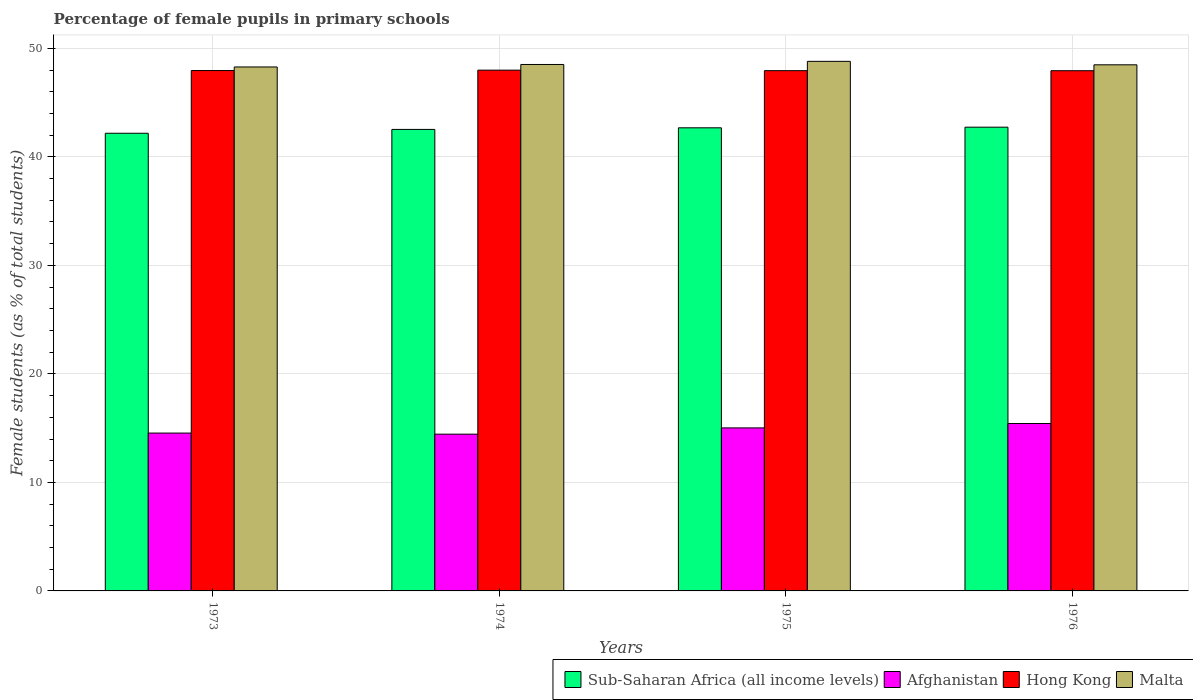How many different coloured bars are there?
Ensure brevity in your answer.  4. How many groups of bars are there?
Provide a succinct answer. 4. Are the number of bars per tick equal to the number of legend labels?
Your answer should be compact. Yes. Are the number of bars on each tick of the X-axis equal?
Your answer should be very brief. Yes. How many bars are there on the 4th tick from the right?
Offer a very short reply. 4. What is the label of the 2nd group of bars from the left?
Provide a short and direct response. 1974. What is the percentage of female pupils in primary schools in Hong Kong in 1975?
Make the answer very short. 47.94. Across all years, what is the maximum percentage of female pupils in primary schools in Hong Kong?
Your answer should be compact. 47.99. Across all years, what is the minimum percentage of female pupils in primary schools in Afghanistan?
Your response must be concise. 14.45. In which year was the percentage of female pupils in primary schools in Afghanistan maximum?
Your answer should be very brief. 1976. In which year was the percentage of female pupils in primary schools in Sub-Saharan Africa (all income levels) minimum?
Ensure brevity in your answer.  1973. What is the total percentage of female pupils in primary schools in Sub-Saharan Africa (all income levels) in the graph?
Give a very brief answer. 170.12. What is the difference between the percentage of female pupils in primary schools in Hong Kong in 1974 and that in 1975?
Give a very brief answer. 0.05. What is the difference between the percentage of female pupils in primary schools in Sub-Saharan Africa (all income levels) in 1975 and the percentage of female pupils in primary schools in Hong Kong in 1974?
Provide a succinct answer. -5.31. What is the average percentage of female pupils in primary schools in Malta per year?
Ensure brevity in your answer.  48.52. In the year 1973, what is the difference between the percentage of female pupils in primary schools in Afghanistan and percentage of female pupils in primary schools in Hong Kong?
Your answer should be very brief. -33.41. What is the ratio of the percentage of female pupils in primary schools in Hong Kong in 1975 to that in 1976?
Provide a short and direct response. 1. What is the difference between the highest and the second highest percentage of female pupils in primary schools in Hong Kong?
Offer a very short reply. 0.04. What is the difference between the highest and the lowest percentage of female pupils in primary schools in Sub-Saharan Africa (all income levels)?
Provide a short and direct response. 0.56. In how many years, is the percentage of female pupils in primary schools in Malta greater than the average percentage of female pupils in primary schools in Malta taken over all years?
Your answer should be compact. 1. Is the sum of the percentage of female pupils in primary schools in Sub-Saharan Africa (all income levels) in 1975 and 1976 greater than the maximum percentage of female pupils in primary schools in Hong Kong across all years?
Offer a very short reply. Yes. Is it the case that in every year, the sum of the percentage of female pupils in primary schools in Sub-Saharan Africa (all income levels) and percentage of female pupils in primary schools in Afghanistan is greater than the sum of percentage of female pupils in primary schools in Hong Kong and percentage of female pupils in primary schools in Malta?
Your response must be concise. No. What does the 2nd bar from the left in 1976 represents?
Your response must be concise. Afghanistan. What does the 4th bar from the right in 1975 represents?
Make the answer very short. Sub-Saharan Africa (all income levels). Is it the case that in every year, the sum of the percentage of female pupils in primary schools in Sub-Saharan Africa (all income levels) and percentage of female pupils in primary schools in Hong Kong is greater than the percentage of female pupils in primary schools in Malta?
Give a very brief answer. Yes. Are all the bars in the graph horizontal?
Provide a succinct answer. No. What is the difference between two consecutive major ticks on the Y-axis?
Offer a terse response. 10. Does the graph contain any zero values?
Your answer should be very brief. No. Does the graph contain grids?
Ensure brevity in your answer.  Yes. Where does the legend appear in the graph?
Your response must be concise. Bottom right. How many legend labels are there?
Keep it short and to the point. 4. How are the legend labels stacked?
Provide a short and direct response. Horizontal. What is the title of the graph?
Keep it short and to the point. Percentage of female pupils in primary schools. Does "Singapore" appear as one of the legend labels in the graph?
Keep it short and to the point. No. What is the label or title of the Y-axis?
Provide a succinct answer. Female students (as % of total students). What is the Female students (as % of total students) of Sub-Saharan Africa (all income levels) in 1973?
Offer a terse response. 42.18. What is the Female students (as % of total students) in Afghanistan in 1973?
Your response must be concise. 14.55. What is the Female students (as % of total students) of Hong Kong in 1973?
Give a very brief answer. 47.96. What is the Female students (as % of total students) of Malta in 1973?
Keep it short and to the point. 48.29. What is the Female students (as % of total students) of Sub-Saharan Africa (all income levels) in 1974?
Provide a short and direct response. 42.53. What is the Female students (as % of total students) of Afghanistan in 1974?
Your answer should be compact. 14.45. What is the Female students (as % of total students) in Hong Kong in 1974?
Keep it short and to the point. 47.99. What is the Female students (as % of total students) in Malta in 1974?
Make the answer very short. 48.52. What is the Female students (as % of total students) of Sub-Saharan Africa (all income levels) in 1975?
Your response must be concise. 42.68. What is the Female students (as % of total students) of Afghanistan in 1975?
Provide a succinct answer. 15.02. What is the Female students (as % of total students) of Hong Kong in 1975?
Provide a succinct answer. 47.94. What is the Female students (as % of total students) of Malta in 1975?
Make the answer very short. 48.8. What is the Female students (as % of total students) in Sub-Saharan Africa (all income levels) in 1976?
Ensure brevity in your answer.  42.74. What is the Female students (as % of total students) of Afghanistan in 1976?
Offer a terse response. 15.43. What is the Female students (as % of total students) in Hong Kong in 1976?
Your answer should be compact. 47.94. What is the Female students (as % of total students) in Malta in 1976?
Give a very brief answer. 48.48. Across all years, what is the maximum Female students (as % of total students) in Sub-Saharan Africa (all income levels)?
Make the answer very short. 42.74. Across all years, what is the maximum Female students (as % of total students) in Afghanistan?
Provide a short and direct response. 15.43. Across all years, what is the maximum Female students (as % of total students) of Hong Kong?
Your response must be concise. 47.99. Across all years, what is the maximum Female students (as % of total students) in Malta?
Make the answer very short. 48.8. Across all years, what is the minimum Female students (as % of total students) of Sub-Saharan Africa (all income levels)?
Ensure brevity in your answer.  42.18. Across all years, what is the minimum Female students (as % of total students) in Afghanistan?
Provide a short and direct response. 14.45. Across all years, what is the minimum Female students (as % of total students) in Hong Kong?
Offer a terse response. 47.94. Across all years, what is the minimum Female students (as % of total students) of Malta?
Your response must be concise. 48.29. What is the total Female students (as % of total students) in Sub-Saharan Africa (all income levels) in the graph?
Your response must be concise. 170.12. What is the total Female students (as % of total students) of Afghanistan in the graph?
Keep it short and to the point. 59.45. What is the total Female students (as % of total students) in Hong Kong in the graph?
Your response must be concise. 191.84. What is the total Female students (as % of total students) of Malta in the graph?
Offer a terse response. 194.09. What is the difference between the Female students (as % of total students) of Sub-Saharan Africa (all income levels) in 1973 and that in 1974?
Your response must be concise. -0.35. What is the difference between the Female students (as % of total students) in Afghanistan in 1973 and that in 1974?
Your response must be concise. 0.1. What is the difference between the Female students (as % of total students) of Hong Kong in 1973 and that in 1974?
Ensure brevity in your answer.  -0.04. What is the difference between the Female students (as % of total students) in Malta in 1973 and that in 1974?
Give a very brief answer. -0.23. What is the difference between the Female students (as % of total students) in Sub-Saharan Africa (all income levels) in 1973 and that in 1975?
Your answer should be compact. -0.5. What is the difference between the Female students (as % of total students) of Afghanistan in 1973 and that in 1975?
Your answer should be compact. -0.48. What is the difference between the Female students (as % of total students) of Hong Kong in 1973 and that in 1975?
Ensure brevity in your answer.  0.01. What is the difference between the Female students (as % of total students) of Malta in 1973 and that in 1975?
Your answer should be compact. -0.52. What is the difference between the Female students (as % of total students) in Sub-Saharan Africa (all income levels) in 1973 and that in 1976?
Keep it short and to the point. -0.56. What is the difference between the Female students (as % of total students) in Afghanistan in 1973 and that in 1976?
Your response must be concise. -0.88. What is the difference between the Female students (as % of total students) of Hong Kong in 1973 and that in 1976?
Your response must be concise. 0.02. What is the difference between the Female students (as % of total students) of Malta in 1973 and that in 1976?
Offer a very short reply. -0.2. What is the difference between the Female students (as % of total students) of Sub-Saharan Africa (all income levels) in 1974 and that in 1975?
Your answer should be very brief. -0.15. What is the difference between the Female students (as % of total students) in Afghanistan in 1974 and that in 1975?
Offer a terse response. -0.58. What is the difference between the Female students (as % of total students) in Hong Kong in 1974 and that in 1975?
Make the answer very short. 0.05. What is the difference between the Female students (as % of total students) of Malta in 1974 and that in 1975?
Offer a very short reply. -0.29. What is the difference between the Female students (as % of total students) in Sub-Saharan Africa (all income levels) in 1974 and that in 1976?
Provide a succinct answer. -0.21. What is the difference between the Female students (as % of total students) of Afghanistan in 1974 and that in 1976?
Give a very brief answer. -0.98. What is the difference between the Female students (as % of total students) in Hong Kong in 1974 and that in 1976?
Offer a terse response. 0.05. What is the difference between the Female students (as % of total students) of Malta in 1974 and that in 1976?
Your response must be concise. 0.03. What is the difference between the Female students (as % of total students) of Sub-Saharan Africa (all income levels) in 1975 and that in 1976?
Provide a succinct answer. -0.06. What is the difference between the Female students (as % of total students) in Afghanistan in 1975 and that in 1976?
Offer a very short reply. -0.41. What is the difference between the Female students (as % of total students) of Hong Kong in 1975 and that in 1976?
Keep it short and to the point. 0. What is the difference between the Female students (as % of total students) in Malta in 1975 and that in 1976?
Provide a short and direct response. 0.32. What is the difference between the Female students (as % of total students) of Sub-Saharan Africa (all income levels) in 1973 and the Female students (as % of total students) of Afghanistan in 1974?
Ensure brevity in your answer.  27.73. What is the difference between the Female students (as % of total students) in Sub-Saharan Africa (all income levels) in 1973 and the Female students (as % of total students) in Hong Kong in 1974?
Give a very brief answer. -5.82. What is the difference between the Female students (as % of total students) of Sub-Saharan Africa (all income levels) in 1973 and the Female students (as % of total students) of Malta in 1974?
Your response must be concise. -6.34. What is the difference between the Female students (as % of total students) in Afghanistan in 1973 and the Female students (as % of total students) in Hong Kong in 1974?
Provide a succinct answer. -33.45. What is the difference between the Female students (as % of total students) in Afghanistan in 1973 and the Female students (as % of total students) in Malta in 1974?
Keep it short and to the point. -33.97. What is the difference between the Female students (as % of total students) of Hong Kong in 1973 and the Female students (as % of total students) of Malta in 1974?
Provide a short and direct response. -0.56. What is the difference between the Female students (as % of total students) in Sub-Saharan Africa (all income levels) in 1973 and the Female students (as % of total students) in Afghanistan in 1975?
Offer a terse response. 27.15. What is the difference between the Female students (as % of total students) of Sub-Saharan Africa (all income levels) in 1973 and the Female students (as % of total students) of Hong Kong in 1975?
Ensure brevity in your answer.  -5.77. What is the difference between the Female students (as % of total students) in Sub-Saharan Africa (all income levels) in 1973 and the Female students (as % of total students) in Malta in 1975?
Your answer should be very brief. -6.63. What is the difference between the Female students (as % of total students) of Afghanistan in 1973 and the Female students (as % of total students) of Hong Kong in 1975?
Your answer should be compact. -33.4. What is the difference between the Female students (as % of total students) of Afghanistan in 1973 and the Female students (as % of total students) of Malta in 1975?
Ensure brevity in your answer.  -34.26. What is the difference between the Female students (as % of total students) of Hong Kong in 1973 and the Female students (as % of total students) of Malta in 1975?
Offer a very short reply. -0.85. What is the difference between the Female students (as % of total students) of Sub-Saharan Africa (all income levels) in 1973 and the Female students (as % of total students) of Afghanistan in 1976?
Give a very brief answer. 26.75. What is the difference between the Female students (as % of total students) of Sub-Saharan Africa (all income levels) in 1973 and the Female students (as % of total students) of Hong Kong in 1976?
Your response must be concise. -5.77. What is the difference between the Female students (as % of total students) in Sub-Saharan Africa (all income levels) in 1973 and the Female students (as % of total students) in Malta in 1976?
Your answer should be compact. -6.31. What is the difference between the Female students (as % of total students) in Afghanistan in 1973 and the Female students (as % of total students) in Hong Kong in 1976?
Keep it short and to the point. -33.39. What is the difference between the Female students (as % of total students) of Afghanistan in 1973 and the Female students (as % of total students) of Malta in 1976?
Provide a succinct answer. -33.94. What is the difference between the Female students (as % of total students) of Hong Kong in 1973 and the Female students (as % of total students) of Malta in 1976?
Provide a succinct answer. -0.53. What is the difference between the Female students (as % of total students) in Sub-Saharan Africa (all income levels) in 1974 and the Female students (as % of total students) in Afghanistan in 1975?
Provide a succinct answer. 27.51. What is the difference between the Female students (as % of total students) in Sub-Saharan Africa (all income levels) in 1974 and the Female students (as % of total students) in Hong Kong in 1975?
Make the answer very short. -5.41. What is the difference between the Female students (as % of total students) of Sub-Saharan Africa (all income levels) in 1974 and the Female students (as % of total students) of Malta in 1975?
Give a very brief answer. -6.27. What is the difference between the Female students (as % of total students) in Afghanistan in 1974 and the Female students (as % of total students) in Hong Kong in 1975?
Provide a short and direct response. -33.5. What is the difference between the Female students (as % of total students) in Afghanistan in 1974 and the Female students (as % of total students) in Malta in 1975?
Your answer should be compact. -34.36. What is the difference between the Female students (as % of total students) of Hong Kong in 1974 and the Female students (as % of total students) of Malta in 1975?
Give a very brief answer. -0.81. What is the difference between the Female students (as % of total students) of Sub-Saharan Africa (all income levels) in 1974 and the Female students (as % of total students) of Afghanistan in 1976?
Offer a terse response. 27.1. What is the difference between the Female students (as % of total students) of Sub-Saharan Africa (all income levels) in 1974 and the Female students (as % of total students) of Hong Kong in 1976?
Give a very brief answer. -5.41. What is the difference between the Female students (as % of total students) of Sub-Saharan Africa (all income levels) in 1974 and the Female students (as % of total students) of Malta in 1976?
Provide a short and direct response. -5.95. What is the difference between the Female students (as % of total students) of Afghanistan in 1974 and the Female students (as % of total students) of Hong Kong in 1976?
Offer a very short reply. -33.49. What is the difference between the Female students (as % of total students) of Afghanistan in 1974 and the Female students (as % of total students) of Malta in 1976?
Offer a very short reply. -34.04. What is the difference between the Female students (as % of total students) in Hong Kong in 1974 and the Female students (as % of total students) in Malta in 1976?
Provide a short and direct response. -0.49. What is the difference between the Female students (as % of total students) of Sub-Saharan Africa (all income levels) in 1975 and the Female students (as % of total students) of Afghanistan in 1976?
Provide a short and direct response. 27.25. What is the difference between the Female students (as % of total students) in Sub-Saharan Africa (all income levels) in 1975 and the Female students (as % of total students) in Hong Kong in 1976?
Your answer should be very brief. -5.26. What is the difference between the Female students (as % of total students) of Sub-Saharan Africa (all income levels) in 1975 and the Female students (as % of total students) of Malta in 1976?
Offer a terse response. -5.81. What is the difference between the Female students (as % of total students) in Afghanistan in 1975 and the Female students (as % of total students) in Hong Kong in 1976?
Keep it short and to the point. -32.92. What is the difference between the Female students (as % of total students) of Afghanistan in 1975 and the Female students (as % of total students) of Malta in 1976?
Offer a very short reply. -33.46. What is the difference between the Female students (as % of total students) in Hong Kong in 1975 and the Female students (as % of total students) in Malta in 1976?
Offer a terse response. -0.54. What is the average Female students (as % of total students) in Sub-Saharan Africa (all income levels) per year?
Your answer should be very brief. 42.53. What is the average Female students (as % of total students) in Afghanistan per year?
Keep it short and to the point. 14.86. What is the average Female students (as % of total students) of Hong Kong per year?
Offer a very short reply. 47.96. What is the average Female students (as % of total students) of Malta per year?
Give a very brief answer. 48.52. In the year 1973, what is the difference between the Female students (as % of total students) in Sub-Saharan Africa (all income levels) and Female students (as % of total students) in Afghanistan?
Your answer should be very brief. 27.63. In the year 1973, what is the difference between the Female students (as % of total students) of Sub-Saharan Africa (all income levels) and Female students (as % of total students) of Hong Kong?
Your answer should be very brief. -5.78. In the year 1973, what is the difference between the Female students (as % of total students) in Sub-Saharan Africa (all income levels) and Female students (as % of total students) in Malta?
Give a very brief answer. -6.11. In the year 1973, what is the difference between the Female students (as % of total students) in Afghanistan and Female students (as % of total students) in Hong Kong?
Your response must be concise. -33.41. In the year 1973, what is the difference between the Female students (as % of total students) of Afghanistan and Female students (as % of total students) of Malta?
Offer a very short reply. -33.74. In the year 1973, what is the difference between the Female students (as % of total students) of Hong Kong and Female students (as % of total students) of Malta?
Offer a very short reply. -0.33. In the year 1974, what is the difference between the Female students (as % of total students) in Sub-Saharan Africa (all income levels) and Female students (as % of total students) in Afghanistan?
Make the answer very short. 28.08. In the year 1974, what is the difference between the Female students (as % of total students) of Sub-Saharan Africa (all income levels) and Female students (as % of total students) of Hong Kong?
Make the answer very short. -5.46. In the year 1974, what is the difference between the Female students (as % of total students) of Sub-Saharan Africa (all income levels) and Female students (as % of total students) of Malta?
Provide a succinct answer. -5.99. In the year 1974, what is the difference between the Female students (as % of total students) in Afghanistan and Female students (as % of total students) in Hong Kong?
Provide a succinct answer. -33.55. In the year 1974, what is the difference between the Female students (as % of total students) in Afghanistan and Female students (as % of total students) in Malta?
Offer a terse response. -34.07. In the year 1974, what is the difference between the Female students (as % of total students) of Hong Kong and Female students (as % of total students) of Malta?
Give a very brief answer. -0.52. In the year 1975, what is the difference between the Female students (as % of total students) of Sub-Saharan Africa (all income levels) and Female students (as % of total students) of Afghanistan?
Make the answer very short. 27.65. In the year 1975, what is the difference between the Female students (as % of total students) of Sub-Saharan Africa (all income levels) and Female students (as % of total students) of Hong Kong?
Ensure brevity in your answer.  -5.27. In the year 1975, what is the difference between the Female students (as % of total students) in Sub-Saharan Africa (all income levels) and Female students (as % of total students) in Malta?
Offer a terse response. -6.12. In the year 1975, what is the difference between the Female students (as % of total students) of Afghanistan and Female students (as % of total students) of Hong Kong?
Your answer should be compact. -32.92. In the year 1975, what is the difference between the Female students (as % of total students) of Afghanistan and Female students (as % of total students) of Malta?
Offer a very short reply. -33.78. In the year 1975, what is the difference between the Female students (as % of total students) of Hong Kong and Female students (as % of total students) of Malta?
Keep it short and to the point. -0.86. In the year 1976, what is the difference between the Female students (as % of total students) in Sub-Saharan Africa (all income levels) and Female students (as % of total students) in Afghanistan?
Your answer should be compact. 27.31. In the year 1976, what is the difference between the Female students (as % of total students) in Sub-Saharan Africa (all income levels) and Female students (as % of total students) in Hong Kong?
Provide a short and direct response. -5.2. In the year 1976, what is the difference between the Female students (as % of total students) of Sub-Saharan Africa (all income levels) and Female students (as % of total students) of Malta?
Your answer should be compact. -5.75. In the year 1976, what is the difference between the Female students (as % of total students) of Afghanistan and Female students (as % of total students) of Hong Kong?
Offer a very short reply. -32.51. In the year 1976, what is the difference between the Female students (as % of total students) in Afghanistan and Female students (as % of total students) in Malta?
Provide a short and direct response. -33.05. In the year 1976, what is the difference between the Female students (as % of total students) in Hong Kong and Female students (as % of total students) in Malta?
Your answer should be compact. -0.54. What is the ratio of the Female students (as % of total students) of Hong Kong in 1973 to that in 1974?
Offer a terse response. 1. What is the ratio of the Female students (as % of total students) in Malta in 1973 to that in 1974?
Your answer should be very brief. 1. What is the ratio of the Female students (as % of total students) in Afghanistan in 1973 to that in 1975?
Ensure brevity in your answer.  0.97. What is the ratio of the Female students (as % of total students) in Sub-Saharan Africa (all income levels) in 1973 to that in 1976?
Your response must be concise. 0.99. What is the ratio of the Female students (as % of total students) in Afghanistan in 1973 to that in 1976?
Provide a short and direct response. 0.94. What is the ratio of the Female students (as % of total students) in Afghanistan in 1974 to that in 1975?
Offer a terse response. 0.96. What is the ratio of the Female students (as % of total students) in Hong Kong in 1974 to that in 1975?
Make the answer very short. 1. What is the ratio of the Female students (as % of total students) of Malta in 1974 to that in 1975?
Make the answer very short. 0.99. What is the ratio of the Female students (as % of total students) of Sub-Saharan Africa (all income levels) in 1974 to that in 1976?
Ensure brevity in your answer.  1. What is the ratio of the Female students (as % of total students) in Afghanistan in 1974 to that in 1976?
Make the answer very short. 0.94. What is the ratio of the Female students (as % of total students) in Afghanistan in 1975 to that in 1976?
Provide a short and direct response. 0.97. What is the ratio of the Female students (as % of total students) of Hong Kong in 1975 to that in 1976?
Your answer should be very brief. 1. What is the ratio of the Female students (as % of total students) of Malta in 1975 to that in 1976?
Make the answer very short. 1.01. What is the difference between the highest and the second highest Female students (as % of total students) in Sub-Saharan Africa (all income levels)?
Keep it short and to the point. 0.06. What is the difference between the highest and the second highest Female students (as % of total students) in Afghanistan?
Make the answer very short. 0.41. What is the difference between the highest and the second highest Female students (as % of total students) in Hong Kong?
Make the answer very short. 0.04. What is the difference between the highest and the second highest Female students (as % of total students) of Malta?
Offer a very short reply. 0.29. What is the difference between the highest and the lowest Female students (as % of total students) in Sub-Saharan Africa (all income levels)?
Offer a terse response. 0.56. What is the difference between the highest and the lowest Female students (as % of total students) of Afghanistan?
Your response must be concise. 0.98. What is the difference between the highest and the lowest Female students (as % of total students) in Hong Kong?
Your response must be concise. 0.05. What is the difference between the highest and the lowest Female students (as % of total students) in Malta?
Provide a succinct answer. 0.52. 